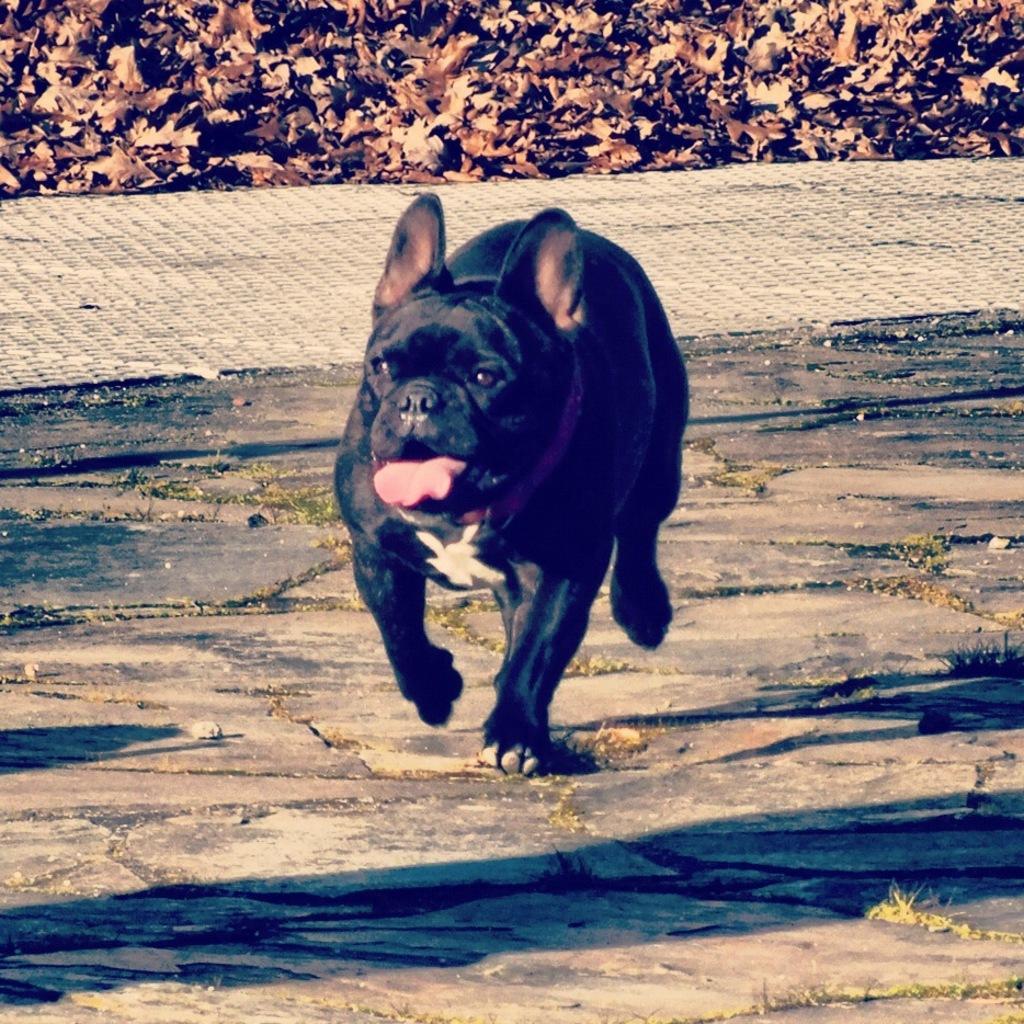Can you describe this image briefly? In the center of the image we can see dog running on the ground. In the background we can see leaves. 